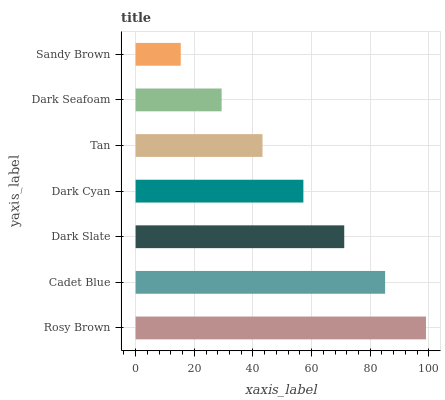Is Sandy Brown the minimum?
Answer yes or no. Yes. Is Rosy Brown the maximum?
Answer yes or no. Yes. Is Cadet Blue the minimum?
Answer yes or no. No. Is Cadet Blue the maximum?
Answer yes or no. No. Is Rosy Brown greater than Cadet Blue?
Answer yes or no. Yes. Is Cadet Blue less than Rosy Brown?
Answer yes or no. Yes. Is Cadet Blue greater than Rosy Brown?
Answer yes or no. No. Is Rosy Brown less than Cadet Blue?
Answer yes or no. No. Is Dark Cyan the high median?
Answer yes or no. Yes. Is Dark Cyan the low median?
Answer yes or no. Yes. Is Sandy Brown the high median?
Answer yes or no. No. Is Sandy Brown the low median?
Answer yes or no. No. 